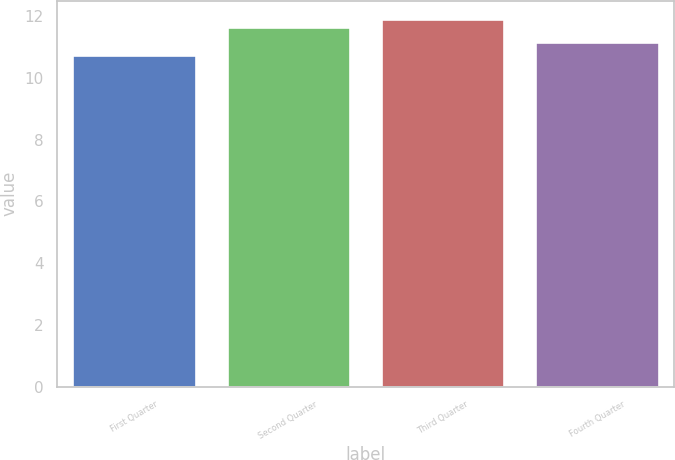<chart> <loc_0><loc_0><loc_500><loc_500><bar_chart><fcel>First Quarter<fcel>Second Quarter<fcel>Third Quarter<fcel>Fourth Quarter<nl><fcel>10.74<fcel>11.65<fcel>11.9<fcel>11.15<nl></chart> 